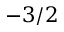<formula> <loc_0><loc_0><loc_500><loc_500>- 3 / 2</formula> 